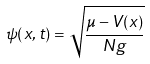Convert formula to latex. <formula><loc_0><loc_0><loc_500><loc_500>\psi ( x , t ) = { \sqrt { \frac { \mu - V ( x ) } { N g } } }</formula> 